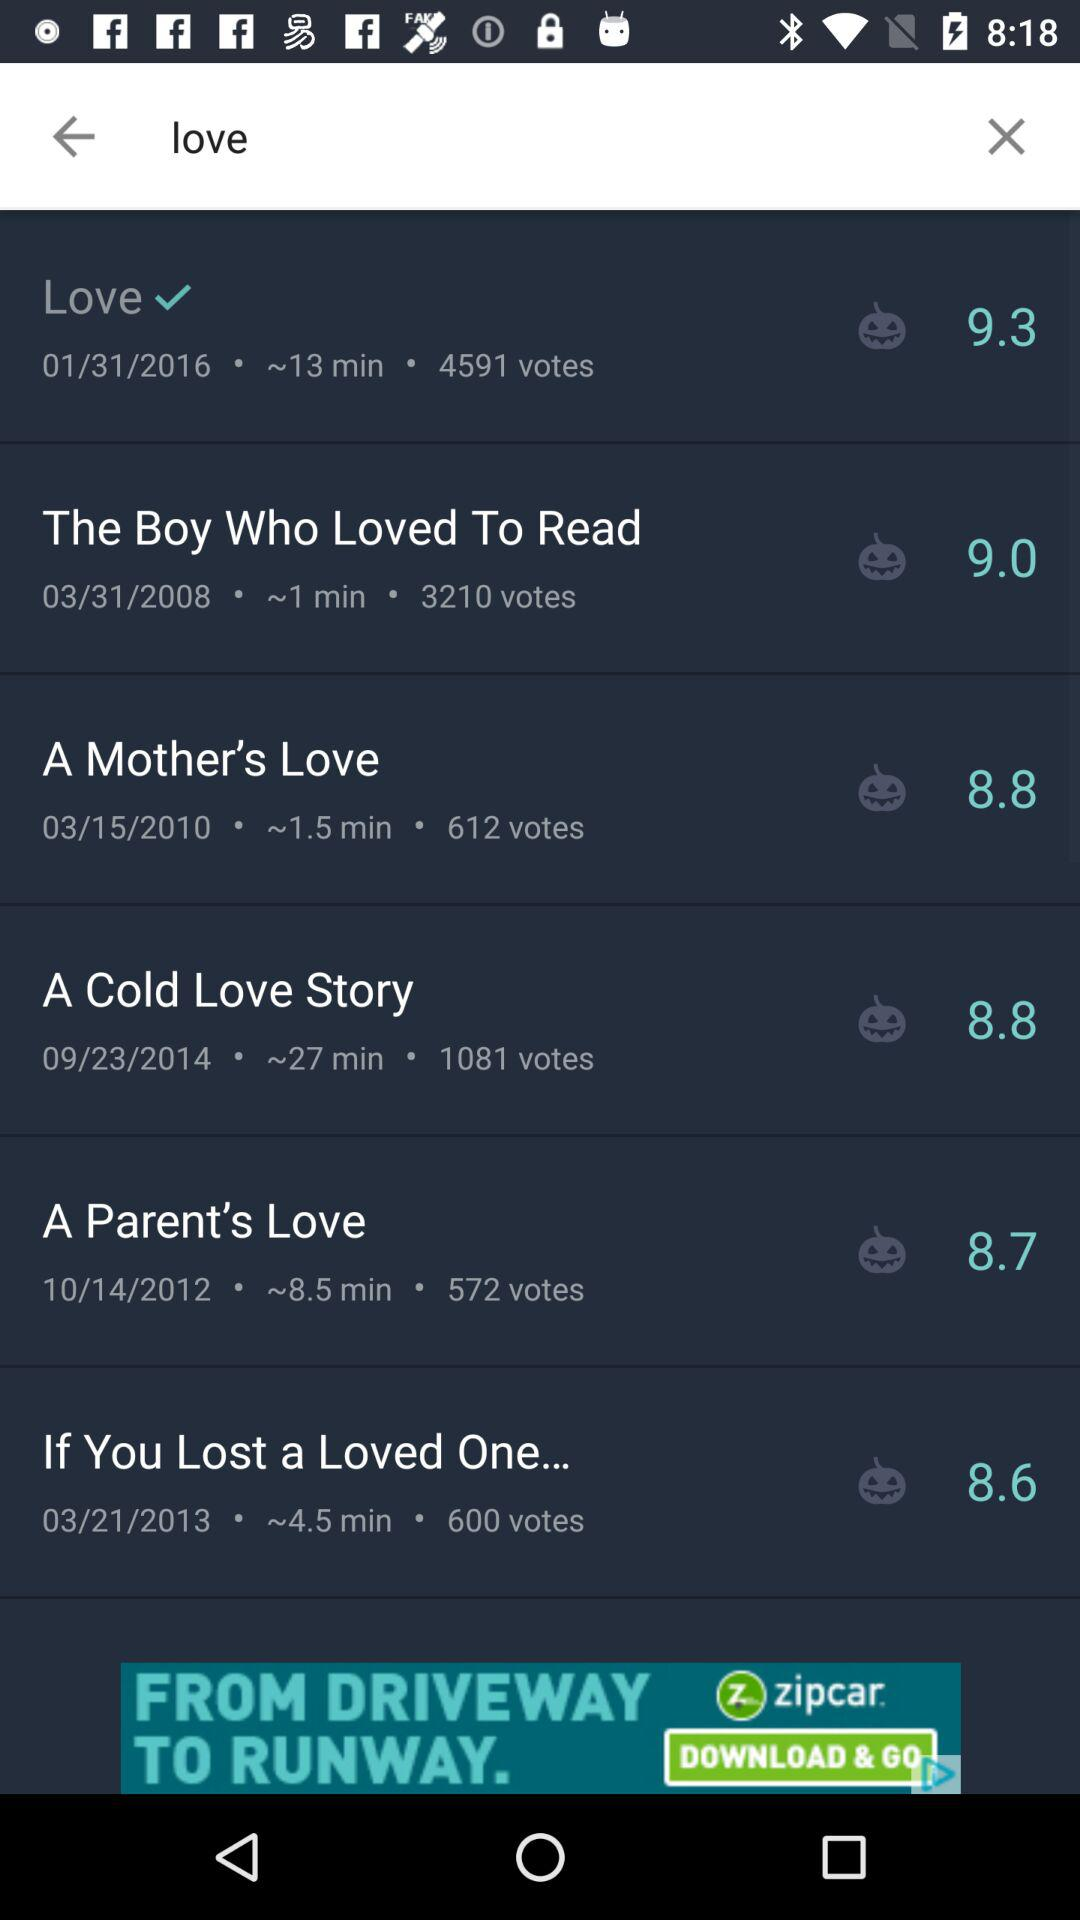What date is mentioned in "A Parent's Love"? The mentioned date is 10/14/2012. 